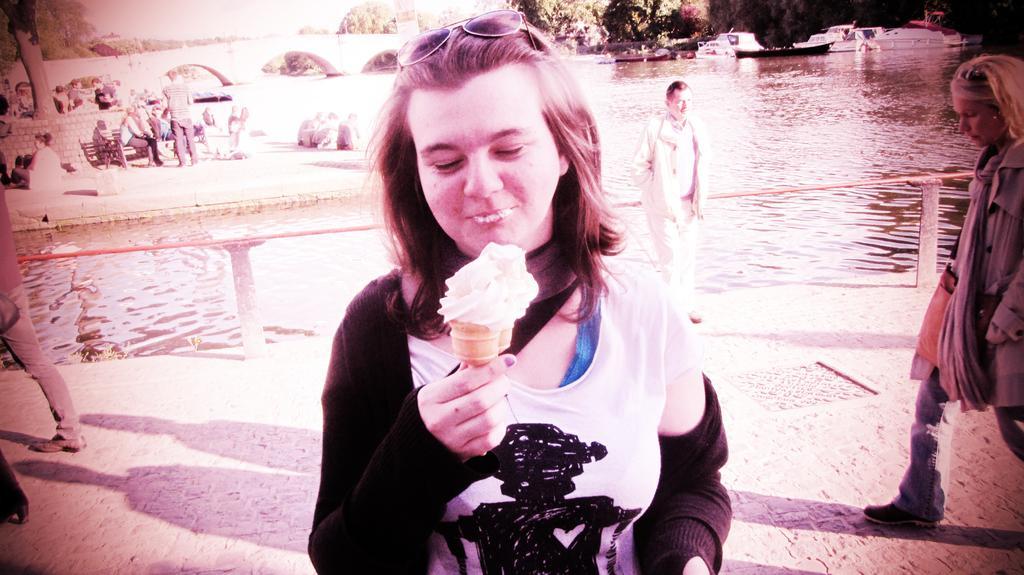Could you give a brief overview of what you see in this image? In front of the picture, we see a woman in white T-shirt and black jacket is holding a cone ice cream in her hands. She is eating it. Behind her, we see a man in the white shirt is standing. On the right side, we see a man in standing. Behind them, we see water and on the left side, we see people sitting on the chairs and under the trees. There are boats sailing in the water. There are trees in the background. 